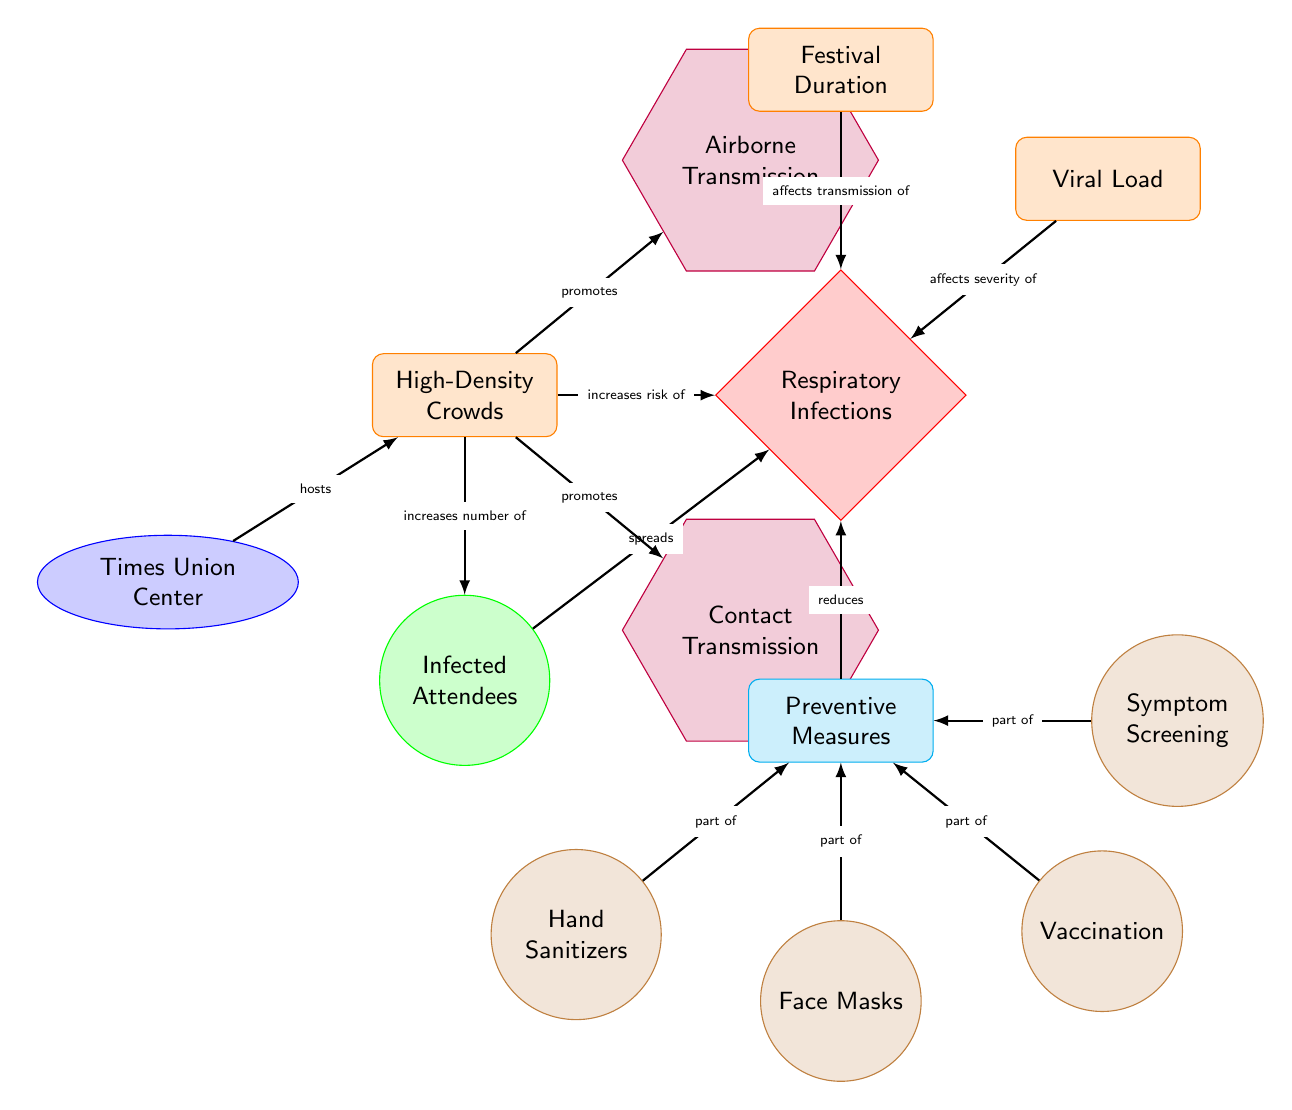What does "High-Density Crowds" promote? The diagram indicates that "High-Density Crowds" promote both "Contact Transmission" and "Airborne Transmission" through directed edges.
Answer: Contact Transmission, Airborne Transmission How many preventive measures are mentioned in the diagram? There are four preventive measures listed in the diagram: "Hand Sanitizers," "Face Masks," "Vaccination," and "Symptom Screening."
Answer: 4 What is the relationship between "Festival Duration" and "Respiratory Infections"? "Festival Duration" affects the transmission of "Respiratory Infections," as indicated by the edge connecting these two nodes.
Answer: Affects transmission of Which location hosts high-density crowds? The node labeled "Times Union Center" is identified in the diagram as the host location for the high-density crowds.
Answer: Times Union Center What does "Infected Attendees" do in the diagram? "Infected Attendees" spreads "Respiratory Infections" as shown by the directed edge originating from it.
Answer: Spreads What role does "Viral Load" play in relation to "Respiratory Infections"? "Viral Load" affects the severity of "Respiratory Infections," as indicated by the edge connecting these two nodes in the diagram.
Answer: Affects severity of How does "Preventive Measures" relate to "Respiratory Infections"? "Preventive Measures" is shown to reduce "Respiratory Infections" in the diagram through a directed relationship.
Answer: Reduces What do "Infected Attendees" increase the number of? "Infected Attendees" increases the number of "Respiratory Infections" according to the diagram's flow.
Answer: Respiratory Infections 